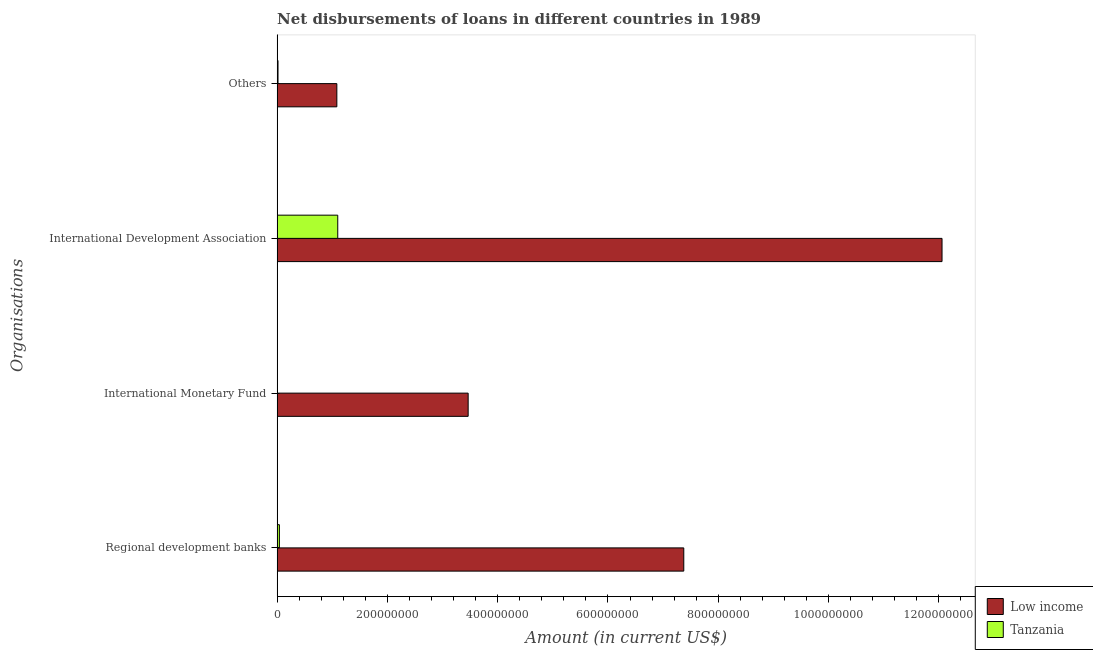How many different coloured bars are there?
Provide a short and direct response. 2. How many bars are there on the 1st tick from the top?
Your answer should be compact. 2. How many bars are there on the 2nd tick from the bottom?
Your response must be concise. 1. What is the label of the 2nd group of bars from the top?
Ensure brevity in your answer.  International Development Association. What is the amount of loan disimbursed by international monetary fund in Low income?
Your answer should be very brief. 3.46e+08. Across all countries, what is the maximum amount of loan disimbursed by other organisations?
Offer a very short reply. 1.08e+08. Across all countries, what is the minimum amount of loan disimbursed by international development association?
Your answer should be very brief. 1.10e+08. What is the total amount of loan disimbursed by international monetary fund in the graph?
Provide a succinct answer. 3.46e+08. What is the difference between the amount of loan disimbursed by international development association in Low income and that in Tanzania?
Your response must be concise. 1.10e+09. What is the difference between the amount of loan disimbursed by regional development banks in Low income and the amount of loan disimbursed by international monetary fund in Tanzania?
Provide a short and direct response. 7.38e+08. What is the average amount of loan disimbursed by international monetary fund per country?
Offer a terse response. 1.73e+08. What is the difference between the amount of loan disimbursed by international monetary fund and amount of loan disimbursed by international development association in Low income?
Your answer should be very brief. -8.59e+08. In how many countries, is the amount of loan disimbursed by regional development banks greater than 1080000000 US$?
Provide a succinct answer. 0. What is the ratio of the amount of loan disimbursed by other organisations in Tanzania to that in Low income?
Offer a very short reply. 0.01. Is the difference between the amount of loan disimbursed by other organisations in Tanzania and Low income greater than the difference between the amount of loan disimbursed by regional development banks in Tanzania and Low income?
Your response must be concise. Yes. What is the difference between the highest and the second highest amount of loan disimbursed by international development association?
Ensure brevity in your answer.  1.10e+09. What is the difference between the highest and the lowest amount of loan disimbursed by other organisations?
Provide a short and direct response. 1.07e+08. Is it the case that in every country, the sum of the amount of loan disimbursed by other organisations and amount of loan disimbursed by regional development banks is greater than the sum of amount of loan disimbursed by international monetary fund and amount of loan disimbursed by international development association?
Your response must be concise. No. Is it the case that in every country, the sum of the amount of loan disimbursed by regional development banks and amount of loan disimbursed by international monetary fund is greater than the amount of loan disimbursed by international development association?
Offer a very short reply. No. How many countries are there in the graph?
Keep it short and to the point. 2. What is the difference between two consecutive major ticks on the X-axis?
Keep it short and to the point. 2.00e+08. Does the graph contain grids?
Ensure brevity in your answer.  No. How many legend labels are there?
Provide a succinct answer. 2. What is the title of the graph?
Ensure brevity in your answer.  Net disbursements of loans in different countries in 1989. What is the label or title of the X-axis?
Provide a succinct answer. Amount (in current US$). What is the label or title of the Y-axis?
Offer a very short reply. Organisations. What is the Amount (in current US$) of Low income in Regional development banks?
Your answer should be compact. 7.38e+08. What is the Amount (in current US$) in Tanzania in Regional development banks?
Give a very brief answer. 4.11e+06. What is the Amount (in current US$) of Low income in International Monetary Fund?
Keep it short and to the point. 3.46e+08. What is the Amount (in current US$) of Tanzania in International Monetary Fund?
Your answer should be compact. 0. What is the Amount (in current US$) in Low income in International Development Association?
Offer a terse response. 1.21e+09. What is the Amount (in current US$) of Tanzania in International Development Association?
Provide a short and direct response. 1.10e+08. What is the Amount (in current US$) of Low income in Others?
Provide a succinct answer. 1.08e+08. What is the Amount (in current US$) of Tanzania in Others?
Ensure brevity in your answer.  1.60e+06. Across all Organisations, what is the maximum Amount (in current US$) of Low income?
Offer a terse response. 1.21e+09. Across all Organisations, what is the maximum Amount (in current US$) in Tanzania?
Provide a short and direct response. 1.10e+08. Across all Organisations, what is the minimum Amount (in current US$) in Low income?
Your response must be concise. 1.08e+08. What is the total Amount (in current US$) in Low income in the graph?
Make the answer very short. 2.40e+09. What is the total Amount (in current US$) of Tanzania in the graph?
Offer a terse response. 1.16e+08. What is the difference between the Amount (in current US$) of Low income in Regional development banks and that in International Monetary Fund?
Provide a succinct answer. 3.91e+08. What is the difference between the Amount (in current US$) of Low income in Regional development banks and that in International Development Association?
Provide a succinct answer. -4.68e+08. What is the difference between the Amount (in current US$) of Tanzania in Regional development banks and that in International Development Association?
Your answer should be compact. -1.06e+08. What is the difference between the Amount (in current US$) of Low income in Regional development banks and that in Others?
Offer a terse response. 6.29e+08. What is the difference between the Amount (in current US$) in Tanzania in Regional development banks and that in Others?
Provide a short and direct response. 2.51e+06. What is the difference between the Amount (in current US$) of Low income in International Monetary Fund and that in International Development Association?
Ensure brevity in your answer.  -8.59e+08. What is the difference between the Amount (in current US$) in Low income in International Monetary Fund and that in Others?
Keep it short and to the point. 2.38e+08. What is the difference between the Amount (in current US$) in Low income in International Development Association and that in Others?
Keep it short and to the point. 1.10e+09. What is the difference between the Amount (in current US$) of Tanzania in International Development Association and that in Others?
Ensure brevity in your answer.  1.08e+08. What is the difference between the Amount (in current US$) in Low income in Regional development banks and the Amount (in current US$) in Tanzania in International Development Association?
Provide a succinct answer. 6.28e+08. What is the difference between the Amount (in current US$) in Low income in Regional development banks and the Amount (in current US$) in Tanzania in Others?
Offer a very short reply. 7.36e+08. What is the difference between the Amount (in current US$) of Low income in International Monetary Fund and the Amount (in current US$) of Tanzania in International Development Association?
Your answer should be compact. 2.37e+08. What is the difference between the Amount (in current US$) in Low income in International Monetary Fund and the Amount (in current US$) in Tanzania in Others?
Ensure brevity in your answer.  3.45e+08. What is the difference between the Amount (in current US$) of Low income in International Development Association and the Amount (in current US$) of Tanzania in Others?
Give a very brief answer. 1.20e+09. What is the average Amount (in current US$) of Low income per Organisations?
Provide a short and direct response. 6.00e+08. What is the average Amount (in current US$) in Tanzania per Organisations?
Offer a very short reply. 2.89e+07. What is the difference between the Amount (in current US$) in Low income and Amount (in current US$) in Tanzania in Regional development banks?
Make the answer very short. 7.33e+08. What is the difference between the Amount (in current US$) in Low income and Amount (in current US$) in Tanzania in International Development Association?
Give a very brief answer. 1.10e+09. What is the difference between the Amount (in current US$) of Low income and Amount (in current US$) of Tanzania in Others?
Provide a short and direct response. 1.07e+08. What is the ratio of the Amount (in current US$) in Low income in Regional development banks to that in International Monetary Fund?
Your answer should be very brief. 2.13. What is the ratio of the Amount (in current US$) of Low income in Regional development banks to that in International Development Association?
Keep it short and to the point. 0.61. What is the ratio of the Amount (in current US$) in Tanzania in Regional development banks to that in International Development Association?
Give a very brief answer. 0.04. What is the ratio of the Amount (in current US$) in Low income in Regional development banks to that in Others?
Your answer should be compact. 6.81. What is the ratio of the Amount (in current US$) of Tanzania in Regional development banks to that in Others?
Your response must be concise. 2.56. What is the ratio of the Amount (in current US$) of Low income in International Monetary Fund to that in International Development Association?
Make the answer very short. 0.29. What is the ratio of the Amount (in current US$) of Low income in International Monetary Fund to that in Others?
Your answer should be very brief. 3.2. What is the ratio of the Amount (in current US$) in Low income in International Development Association to that in Others?
Provide a short and direct response. 11.13. What is the ratio of the Amount (in current US$) in Tanzania in International Development Association to that in Others?
Offer a terse response. 68.54. What is the difference between the highest and the second highest Amount (in current US$) in Low income?
Offer a terse response. 4.68e+08. What is the difference between the highest and the second highest Amount (in current US$) in Tanzania?
Your answer should be very brief. 1.06e+08. What is the difference between the highest and the lowest Amount (in current US$) in Low income?
Provide a succinct answer. 1.10e+09. What is the difference between the highest and the lowest Amount (in current US$) of Tanzania?
Provide a short and direct response. 1.10e+08. 